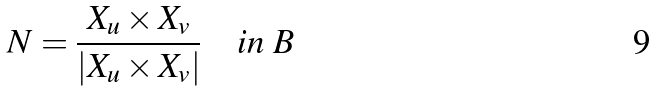<formula> <loc_0><loc_0><loc_500><loc_500>N = \frac { X _ { u } \times X _ { v } } { | X _ { u } \times X _ { v } | } \quad i n \ B</formula> 